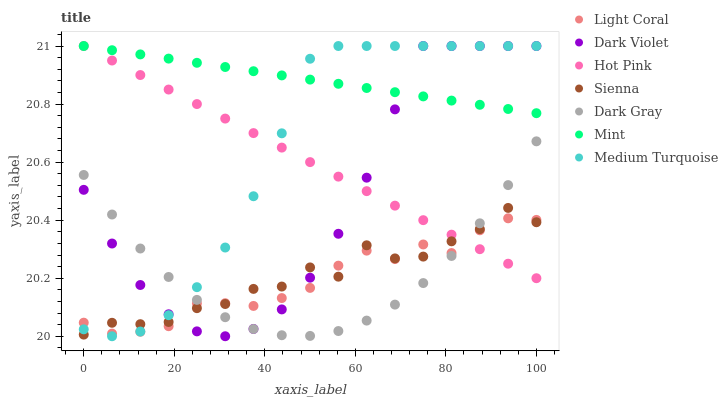Does Light Coral have the minimum area under the curve?
Answer yes or no. Yes. Does Mint have the maximum area under the curve?
Answer yes or no. Yes. Does Hot Pink have the minimum area under the curve?
Answer yes or no. No. Does Hot Pink have the maximum area under the curve?
Answer yes or no. No. Is Mint the smoothest?
Answer yes or no. Yes. Is Sienna the roughest?
Answer yes or no. Yes. Is Hot Pink the smoothest?
Answer yes or no. No. Is Hot Pink the roughest?
Answer yes or no. No. Does Medium Turquoise have the lowest value?
Answer yes or no. Yes. Does Hot Pink have the lowest value?
Answer yes or no. No. Does Mint have the highest value?
Answer yes or no. Yes. Does Light Coral have the highest value?
Answer yes or no. No. Is Sienna less than Mint?
Answer yes or no. Yes. Is Mint greater than Dark Gray?
Answer yes or no. Yes. Does Dark Gray intersect Sienna?
Answer yes or no. Yes. Is Dark Gray less than Sienna?
Answer yes or no. No. Is Dark Gray greater than Sienna?
Answer yes or no. No. Does Sienna intersect Mint?
Answer yes or no. No. 